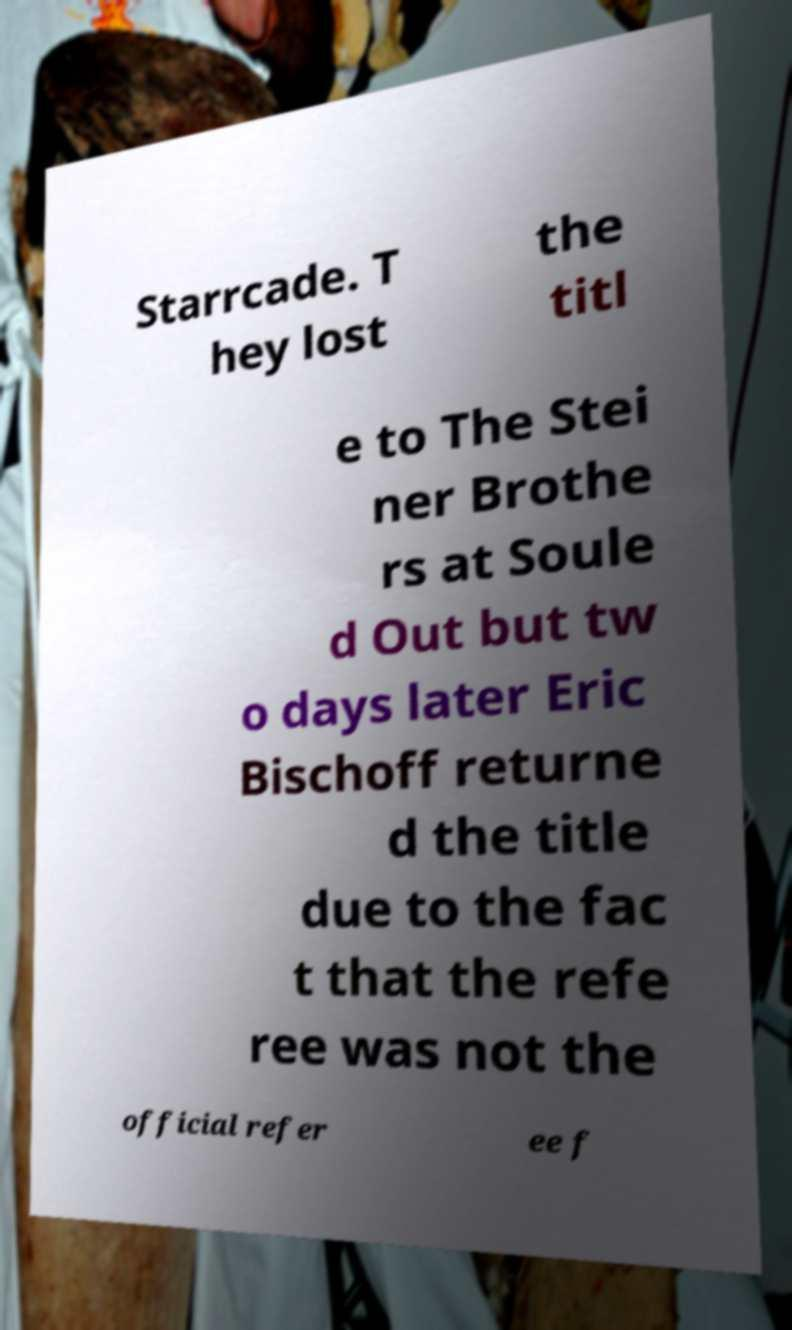Could you assist in decoding the text presented in this image and type it out clearly? Starrcade. T hey lost the titl e to The Stei ner Brothe rs at Soule d Out but tw o days later Eric Bischoff returne d the title due to the fac t that the refe ree was not the official refer ee f 